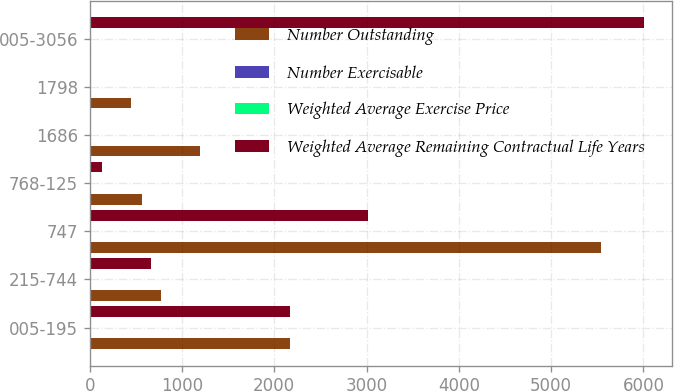Convert chart. <chart><loc_0><loc_0><loc_500><loc_500><stacked_bar_chart><ecel><fcel>005-195<fcel>215-744<fcel>747<fcel>768-125<fcel>1686<fcel>1798<fcel>005-3056<nl><fcel>Number Outstanding<fcel>2175<fcel>775<fcel>5538<fcel>566<fcel>1193<fcel>452<fcel>16.86<nl><fcel>Number Exercisable<fcel>3.45<fcel>5.21<fcel>4.58<fcel>5.53<fcel>6.11<fcel>6.59<fcel>4.8<nl><fcel>Weighted Average Exercise Price<fcel>1.33<fcel>3.33<fcel>7.47<fcel>9.56<fcel>16.86<fcel>17.98<fcel>8.42<nl><fcel>Weighted Average Remaining Contractual Life Years<fcel>2175<fcel>662<fcel>3012<fcel>132<fcel>18<fcel>7<fcel>6006<nl></chart> 